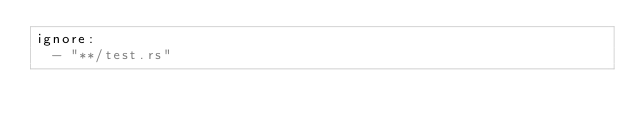<code> <loc_0><loc_0><loc_500><loc_500><_YAML_>ignore:
  - "**/test.rs"</code> 